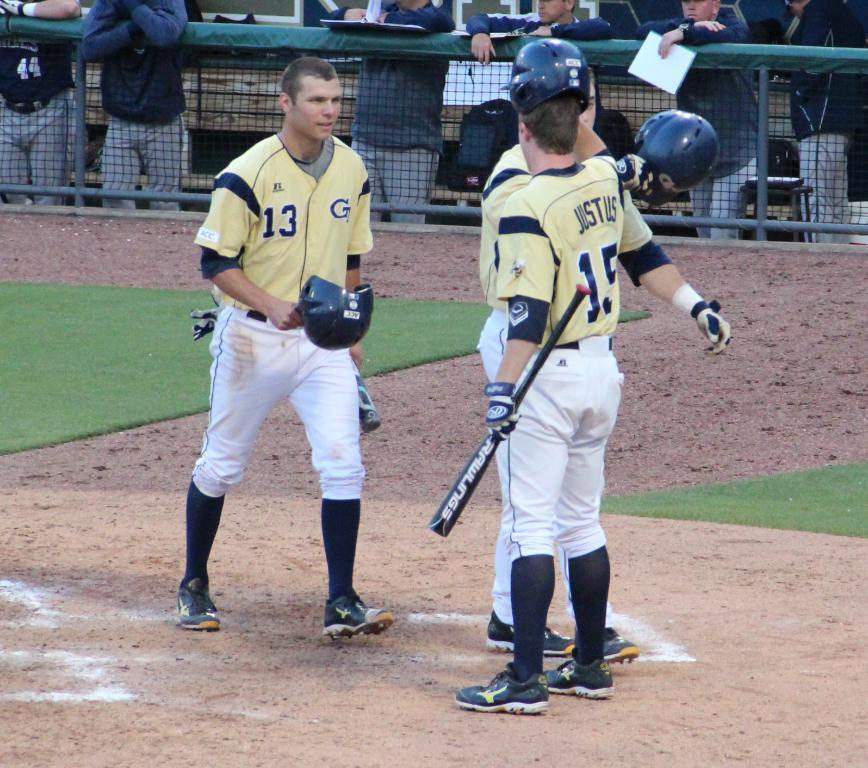<image>
Offer a succinct explanation of the picture presented. A group of men gathered around a baseball base and one has the number 13 on his jersey. 